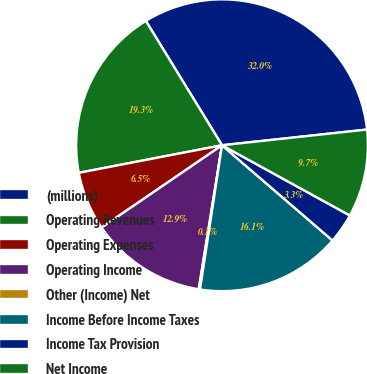Convert chart to OTSL. <chart><loc_0><loc_0><loc_500><loc_500><pie_chart><fcel>(millions)<fcel>Operating Revenues<fcel>Operating Expenses<fcel>Operating Income<fcel>Other (Income) Net<fcel>Income Before Income Taxes<fcel>Income Tax Provision<fcel>Net Income<nl><fcel>32.03%<fcel>19.28%<fcel>6.52%<fcel>12.9%<fcel>0.14%<fcel>16.09%<fcel>3.33%<fcel>9.71%<nl></chart> 